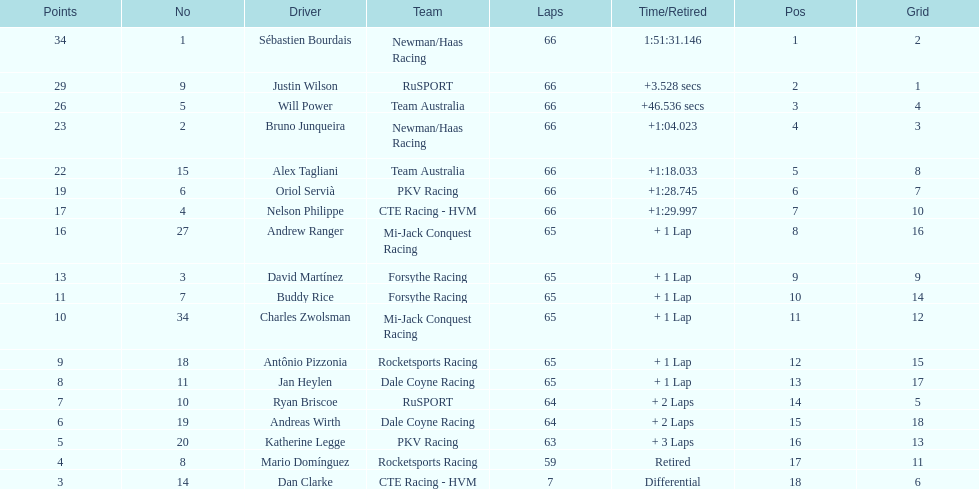Rice finished 10th. who finished next? Charles Zwolsman. 